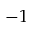<formula> <loc_0><loc_0><loc_500><loc_500>- 1</formula> 